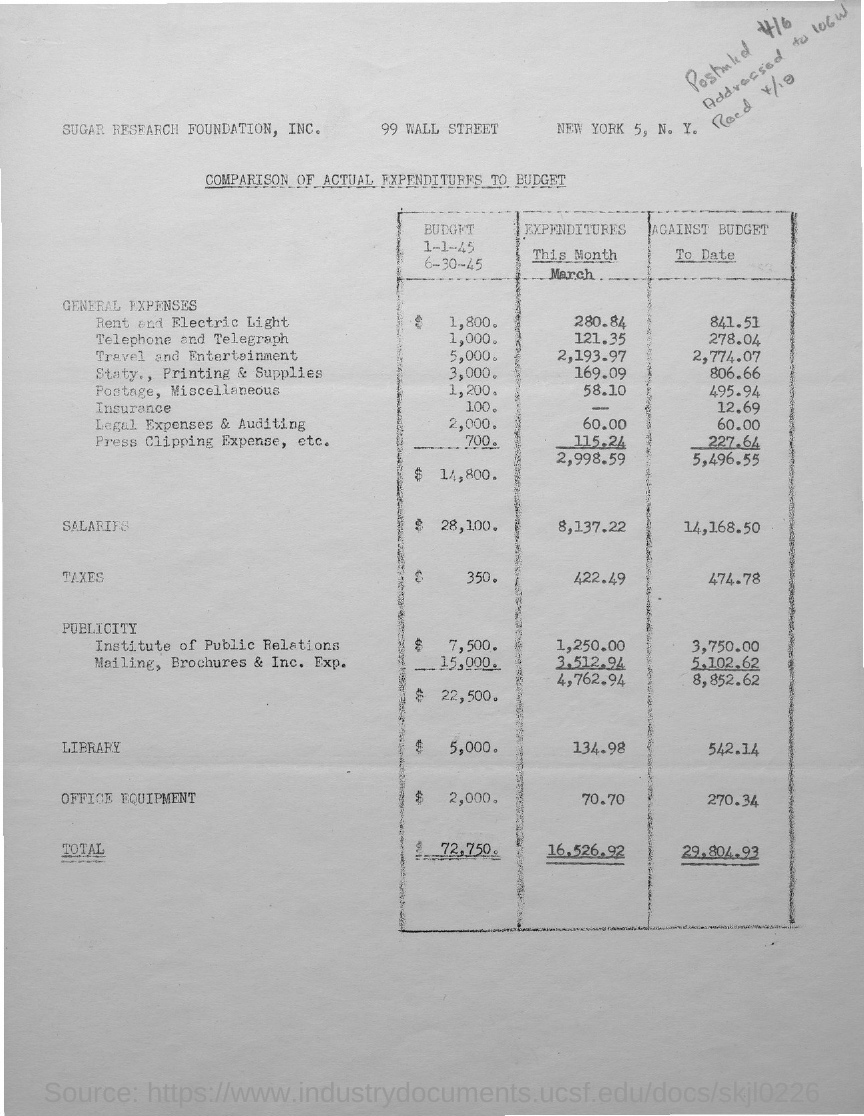Indicate a few pertinent items in this graphic. The general expenses for the month of March were 2,998.59. In the month of March, the salary expenditure was 8,137.22. As of the current budget, the amount of tax is 474.78... The total expenditure for the month of March was 16,526.92. The total amount of salaries against the budget to date is 14,168.50. 